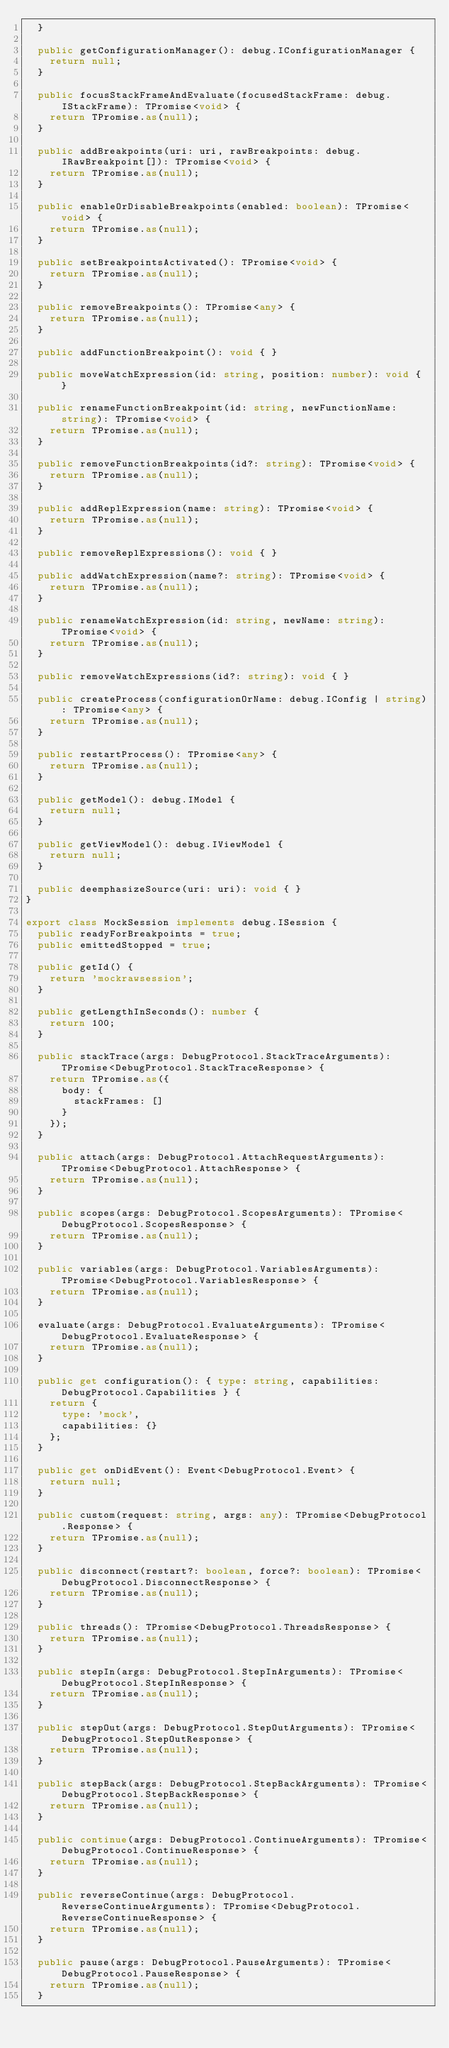Convert code to text. <code><loc_0><loc_0><loc_500><loc_500><_TypeScript_>	}

	public getConfigurationManager(): debug.IConfigurationManager {
		return null;
	}

	public focusStackFrameAndEvaluate(focusedStackFrame: debug.IStackFrame): TPromise<void> {
		return TPromise.as(null);
	}

	public addBreakpoints(uri: uri, rawBreakpoints: debug.IRawBreakpoint[]): TPromise<void> {
		return TPromise.as(null);
	}

	public enableOrDisableBreakpoints(enabled: boolean): TPromise<void> {
		return TPromise.as(null);
	}

	public setBreakpointsActivated(): TPromise<void> {
		return TPromise.as(null);
	}

	public removeBreakpoints(): TPromise<any> {
		return TPromise.as(null);
	}

	public addFunctionBreakpoint(): void { }

	public moveWatchExpression(id: string, position: number): void { }

	public renameFunctionBreakpoint(id: string, newFunctionName: string): TPromise<void> {
		return TPromise.as(null);
	}

	public removeFunctionBreakpoints(id?: string): TPromise<void> {
		return TPromise.as(null);
	}

	public addReplExpression(name: string): TPromise<void> {
		return TPromise.as(null);
	}

	public removeReplExpressions(): void { }

	public addWatchExpression(name?: string): TPromise<void> {
		return TPromise.as(null);
	}

	public renameWatchExpression(id: string, newName: string): TPromise<void> {
		return TPromise.as(null);
	}

	public removeWatchExpressions(id?: string): void { }

	public createProcess(configurationOrName: debug.IConfig | string): TPromise<any> {
		return TPromise.as(null);
	}

	public restartProcess(): TPromise<any> {
		return TPromise.as(null);
	}

	public getModel(): debug.IModel {
		return null;
	}

	public getViewModel(): debug.IViewModel {
		return null;
	}

	public deemphasizeSource(uri: uri): void { }
}

export class MockSession implements debug.ISession {
	public readyForBreakpoints = true;
	public emittedStopped = true;

	public getId() {
		return 'mockrawsession';
	}

	public getLengthInSeconds(): number {
		return 100;
	}

	public stackTrace(args: DebugProtocol.StackTraceArguments): TPromise<DebugProtocol.StackTraceResponse> {
		return TPromise.as({
			body: {
				stackFrames: []
			}
		});
	}

	public attach(args: DebugProtocol.AttachRequestArguments): TPromise<DebugProtocol.AttachResponse> {
		return TPromise.as(null);
	}

	public scopes(args: DebugProtocol.ScopesArguments): TPromise<DebugProtocol.ScopesResponse> {
		return TPromise.as(null);
	}

	public variables(args: DebugProtocol.VariablesArguments): TPromise<DebugProtocol.VariablesResponse> {
		return TPromise.as(null);
	}

	evaluate(args: DebugProtocol.EvaluateArguments): TPromise<DebugProtocol.EvaluateResponse> {
		return TPromise.as(null);
	}

	public get configuration(): { type: string, capabilities: DebugProtocol.Capabilities } {
		return {
			type: 'mock',
			capabilities: {}
		};
	}

	public get onDidEvent(): Event<DebugProtocol.Event> {
		return null;
	}

	public custom(request: string, args: any): TPromise<DebugProtocol.Response> {
		return TPromise.as(null);
	}

	public disconnect(restart?: boolean, force?: boolean): TPromise<DebugProtocol.DisconnectResponse> {
		return TPromise.as(null);
	}

	public threads(): TPromise<DebugProtocol.ThreadsResponse> {
		return TPromise.as(null);
	}

	public stepIn(args: DebugProtocol.StepInArguments): TPromise<DebugProtocol.StepInResponse> {
		return TPromise.as(null);
	}

	public stepOut(args: DebugProtocol.StepOutArguments): TPromise<DebugProtocol.StepOutResponse> {
		return TPromise.as(null);
	}

	public stepBack(args: DebugProtocol.StepBackArguments): TPromise<DebugProtocol.StepBackResponse> {
		return TPromise.as(null);
	}

	public continue(args: DebugProtocol.ContinueArguments): TPromise<DebugProtocol.ContinueResponse> {
		return TPromise.as(null);
	}

	public reverseContinue(args: DebugProtocol.ReverseContinueArguments): TPromise<DebugProtocol.ReverseContinueResponse> {
		return TPromise.as(null);
	}

	public pause(args: DebugProtocol.PauseArguments): TPromise<DebugProtocol.PauseResponse> {
		return TPromise.as(null);
	}
</code> 